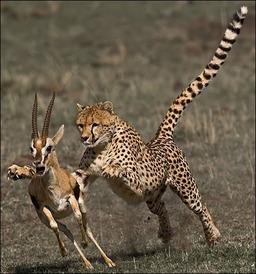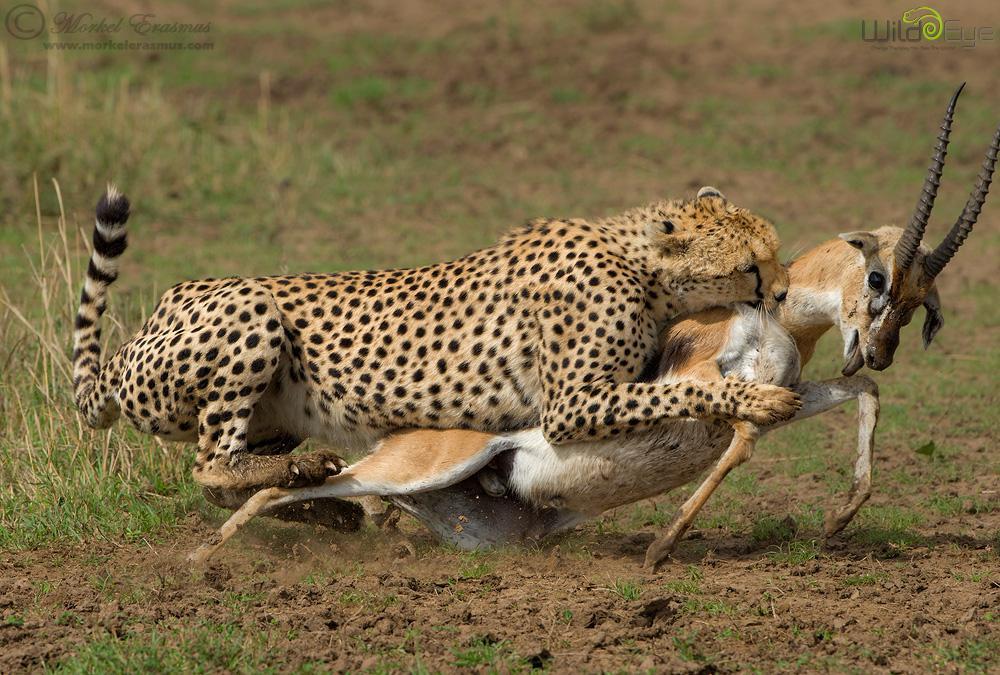The first image is the image on the left, the second image is the image on the right. Analyze the images presented: Is the assertion "At least one of the animals is chasing its prey." valid? Answer yes or no. Yes. The first image is the image on the left, the second image is the image on the right. Considering the images on both sides, is "At least one image shows a spotted wild cat pursuing a gazelle-type prey animal." valid? Answer yes or no. Yes. 